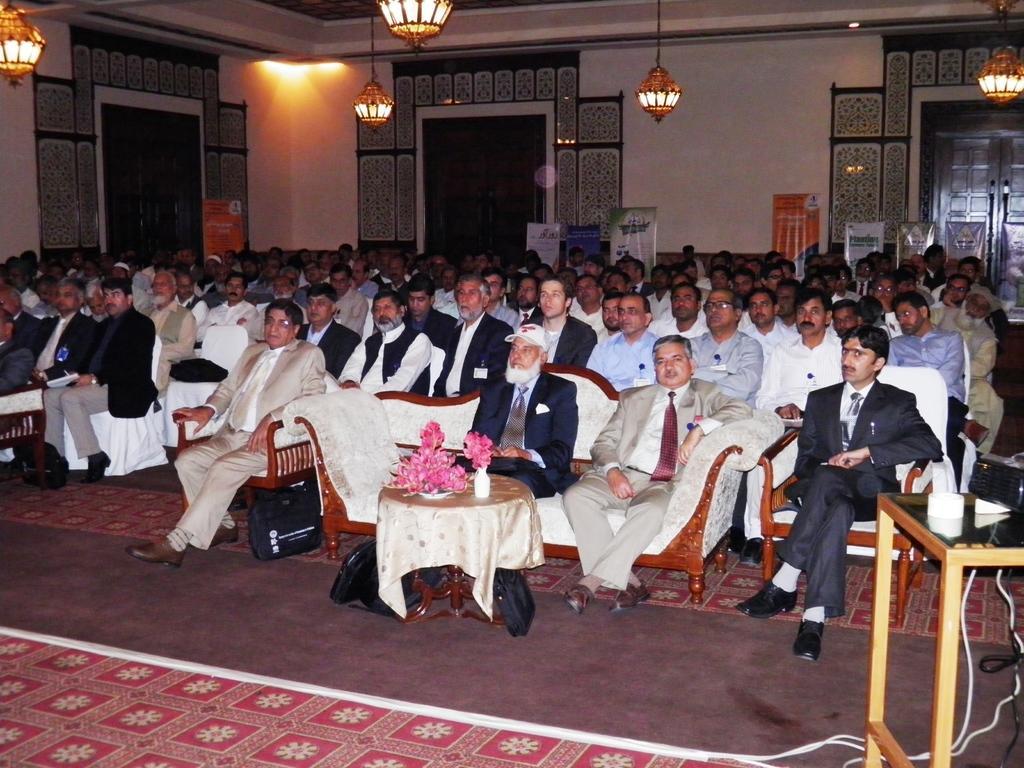In one or two sentences, can you explain what this image depicts? In this Image I see number of people who are sitting on chairs and sofa and there are tables over here on which there are flowers and few things. In the background I see the doors, wall, few boards and lights. 